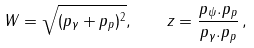Convert formula to latex. <formula><loc_0><loc_0><loc_500><loc_500>W = \sqrt { ( p _ { \gamma } + p _ { p } ) ^ { 2 } } , \quad z = \frac { p _ { \psi } . p _ { p } } { p _ { \gamma } . p _ { p } } \, ,</formula> 